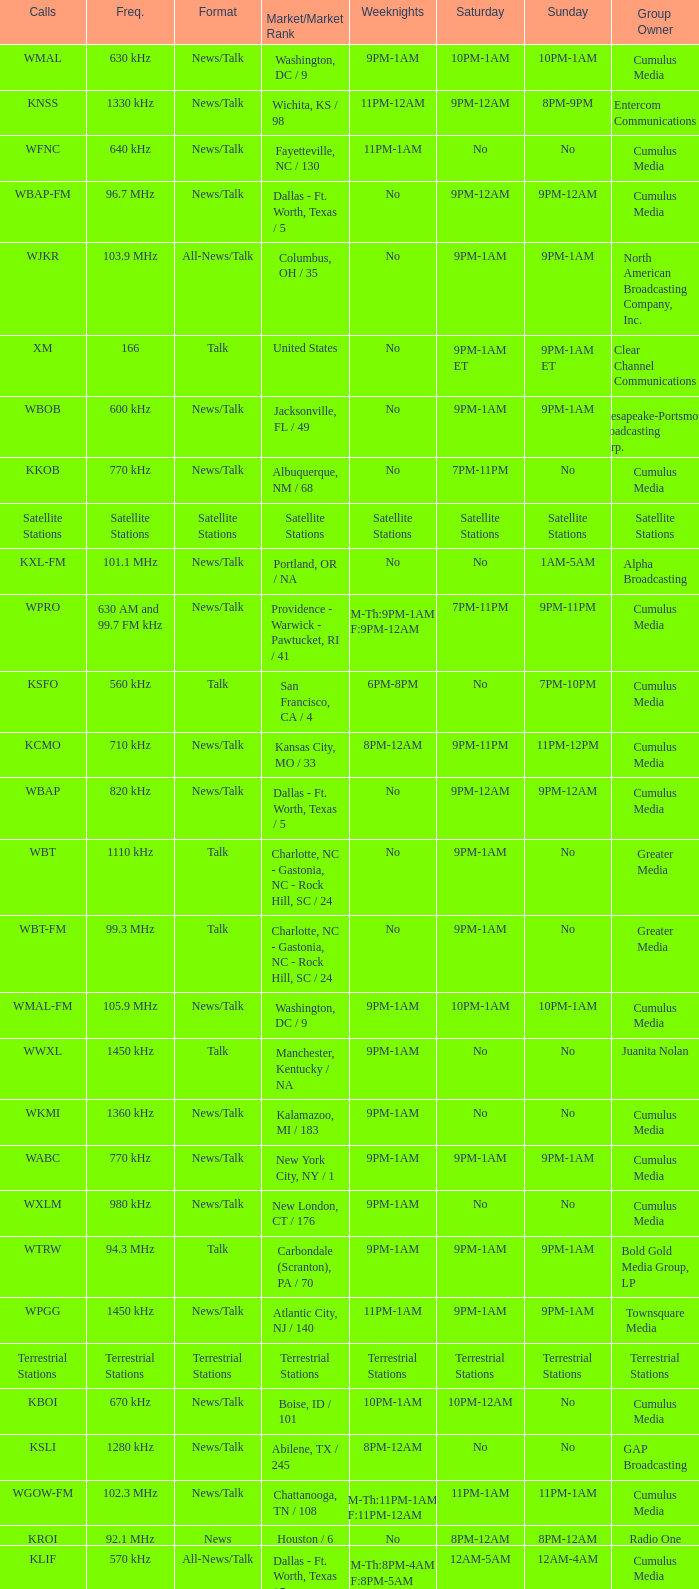What is the market for the 11pm-1am Saturday game? Chattanooga, TN / 108. 